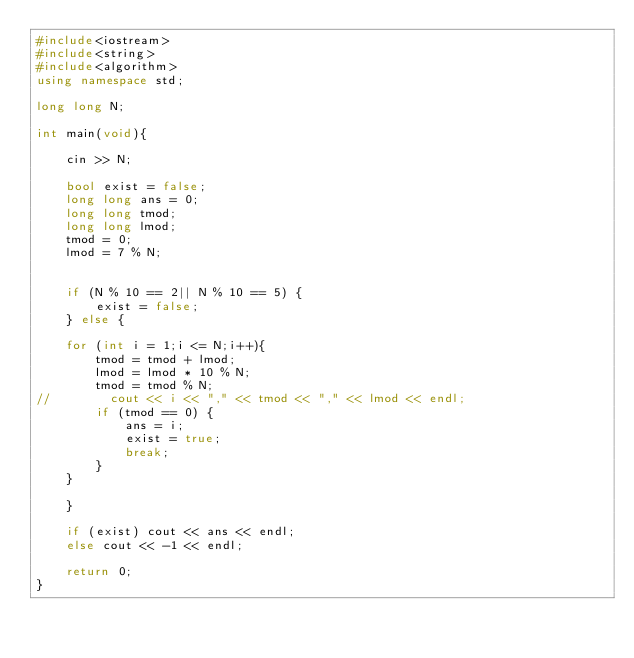<code> <loc_0><loc_0><loc_500><loc_500><_C++_>#include<iostream>
#include<string>
#include<algorithm>
using namespace std;

long long N;

int main(void){

    cin >> N;

    bool exist = false;
    long long ans = 0;
    long long tmod;
    long long lmod;
    tmod = 0;
    lmod = 7 % N;


    if (N % 10 == 2|| N % 10 == 5) {
        exist = false;
    } else {

    for (int i = 1;i <= N;i++){
        tmod = tmod + lmod;
        lmod = lmod * 10 % N;
        tmod = tmod % N;
//        cout << i << "," << tmod << "," << lmod << endl;
        if (tmod == 0) {
            ans = i;
            exist = true;
            break;
        }
    }

    }

    if (exist) cout << ans << endl;
    else cout << -1 << endl;

    return 0;
}</code> 